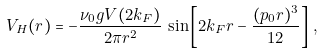<formula> <loc_0><loc_0><loc_500><loc_500>V _ { H } ( r ) = - \frac { \nu _ { 0 } g V ( 2 k _ { F } ) } { 2 \pi r ^ { 2 } } \, \sin \left [ 2 k _ { F } r - \frac { ( p _ { 0 } r ) ^ { 3 } } { 1 2 } \right ] \, ,</formula> 